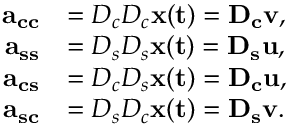<formula> <loc_0><loc_0><loc_500><loc_500>\begin{array} { r l } { a _ { c c } } & { = D _ { c } D _ { c } x ( t ) = D _ { c } { v } , } \\ { a _ { s s } } & { = D _ { s } D _ { s } x ( t ) = D _ { s } { u } , } \\ { a _ { c s } } & { = D _ { c } D _ { s } x ( t ) = D _ { c } { u } , } \\ { a _ { s c } } & { = D _ { s } D _ { c } x ( t ) = D _ { s } { v } . } \end{array}</formula> 